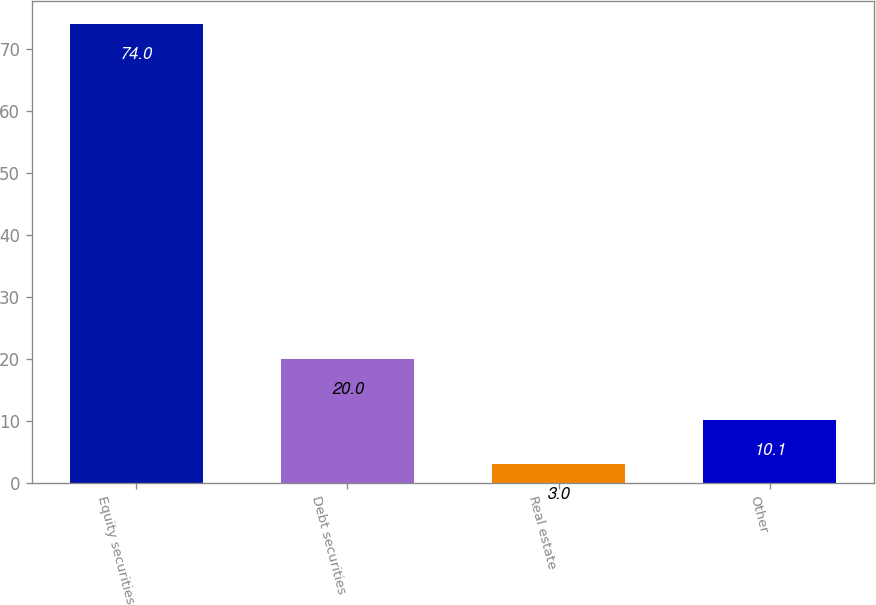Convert chart. <chart><loc_0><loc_0><loc_500><loc_500><bar_chart><fcel>Equity securities<fcel>Debt securities<fcel>Real estate<fcel>Other<nl><fcel>74<fcel>20<fcel>3<fcel>10.1<nl></chart> 